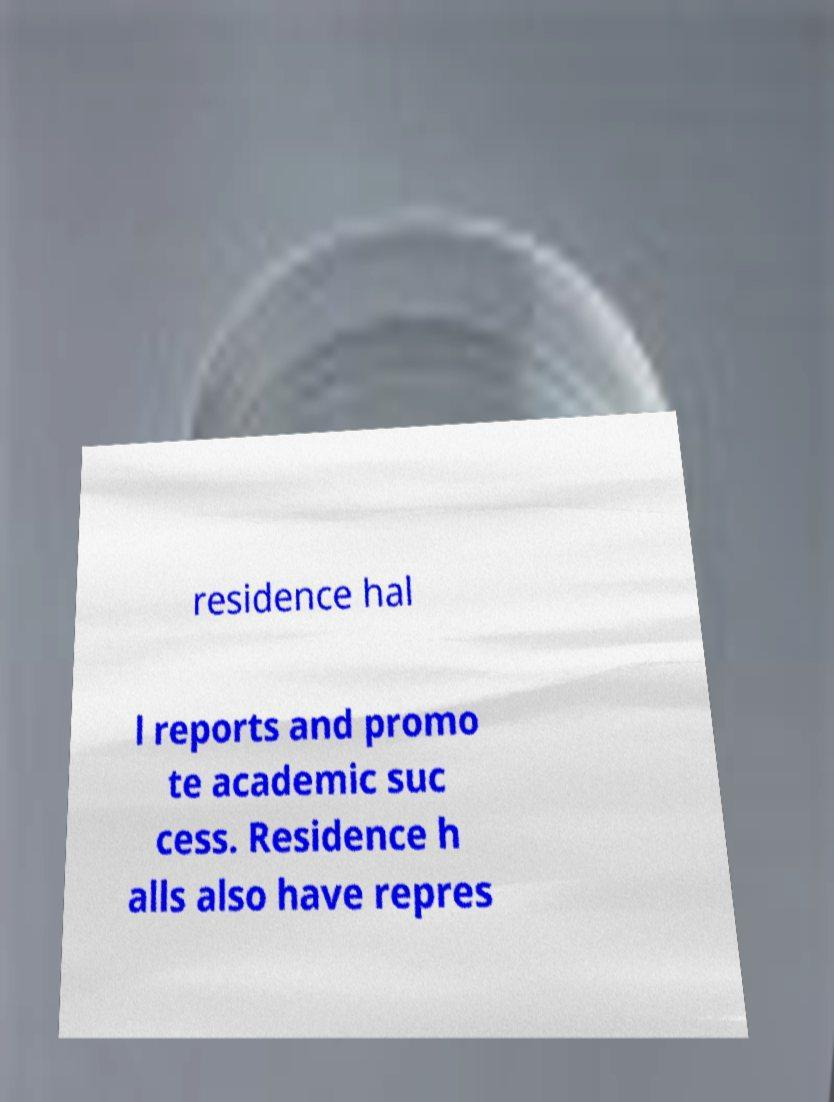Please read and relay the text visible in this image. What does it say? residence hal l reports and promo te academic suc cess. Residence h alls also have repres 